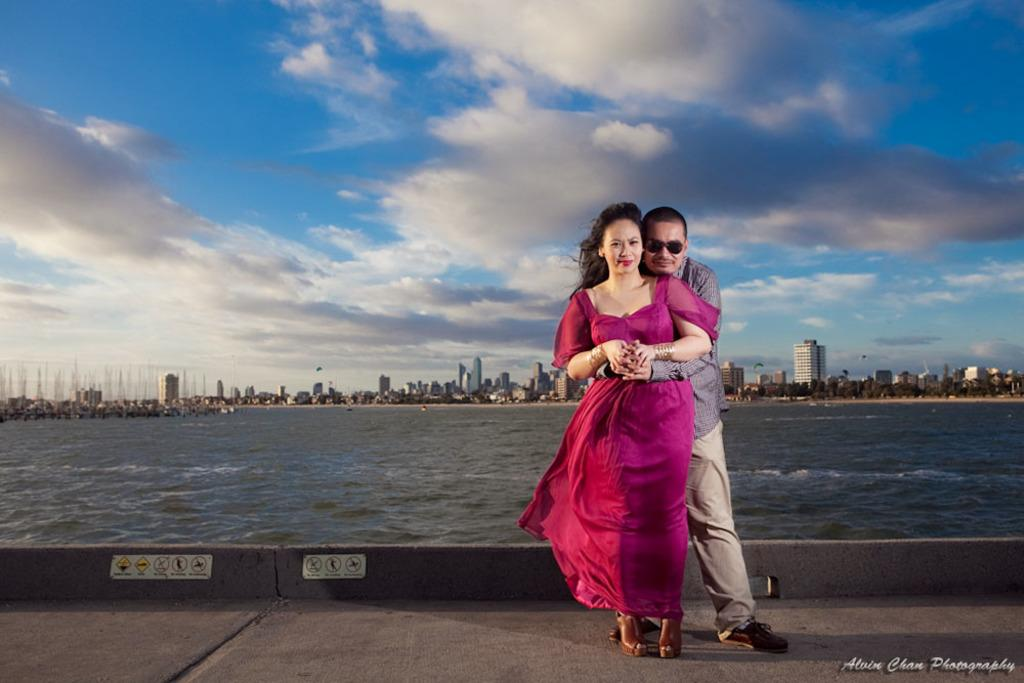What are the two persons in the image doing? The two persons in the image are standing and hugging each other. What can be seen in the background of the image? Water, skyscrapers, trees, and the sky are visible in the background of the image. Can you describe the water in the background? The water is visible in the background, but its specific characteristics are not mentioned in the facts. Is there any text or logo on the image? Yes, there is a watermark on the image. Reasoning: Let's think step by step by step in order to produce the conversation. We start by identifying the main action in the image, which is the two persons hugging each other. Then, we describe the background of the image, mentioning the water, skyscrapers, trees, and sky. We avoid asking about the specific characteristics of the water, as it is not mentioned in the facts. Finally, we acknowledge the presence of a watermark on the image. Absurd Question/Answer: How many clovers can be seen growing in the image? There are no clovers present in the image. What type of string is being used to tie the trees together in the image? There is no mention of any string or trees being tied together in the image. 